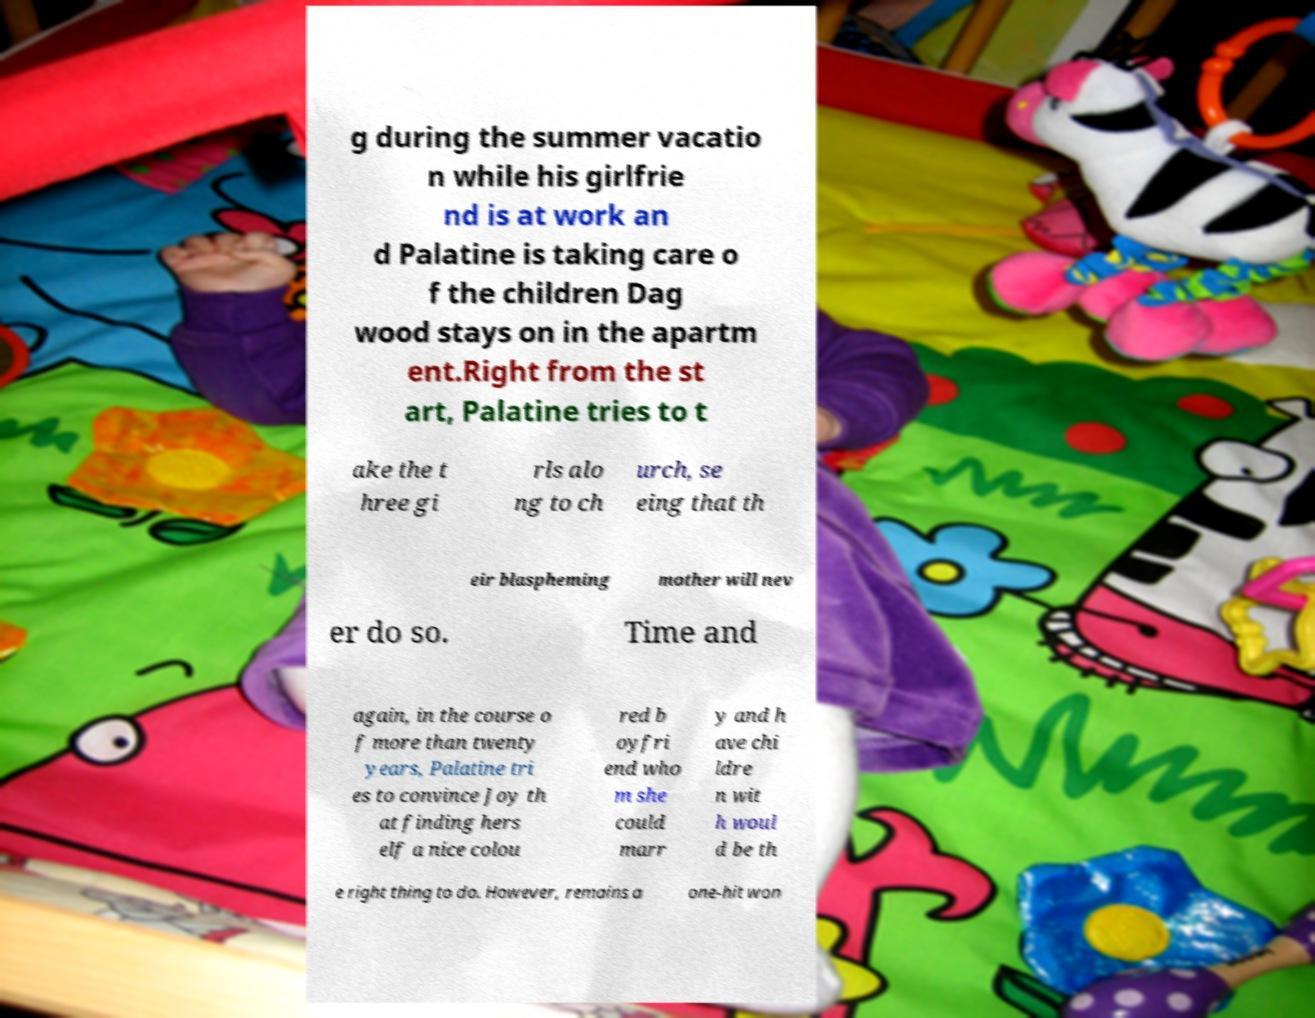There's text embedded in this image that I need extracted. Can you transcribe it verbatim? g during the summer vacatio n while his girlfrie nd is at work an d Palatine is taking care o f the children Dag wood stays on in the apartm ent.Right from the st art, Palatine tries to t ake the t hree gi rls alo ng to ch urch, se eing that th eir blaspheming mother will nev er do so. Time and again, in the course o f more than twenty years, Palatine tri es to convince Joy th at finding hers elf a nice colou red b oyfri end who m she could marr y and h ave chi ldre n wit h woul d be th e right thing to do. However, remains a one-hit won 